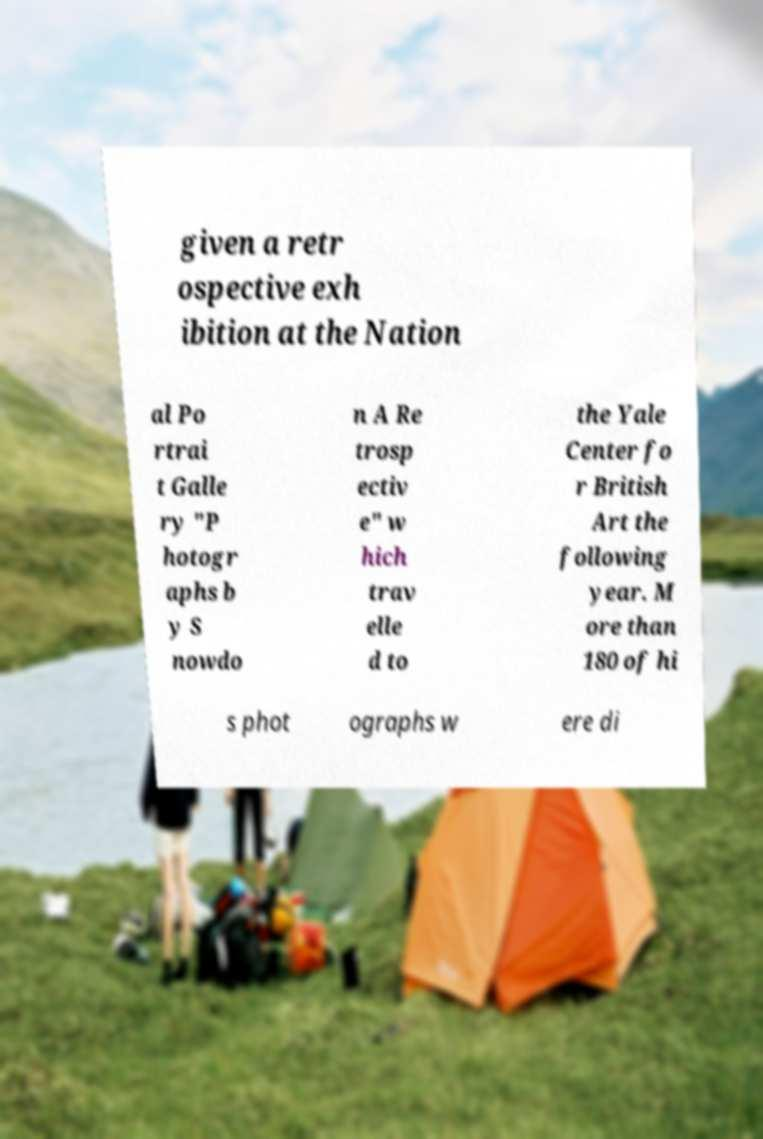Could you extract and type out the text from this image? given a retr ospective exh ibition at the Nation al Po rtrai t Galle ry "P hotogr aphs b y S nowdo n A Re trosp ectiv e" w hich trav elle d to the Yale Center fo r British Art the following year. M ore than 180 of hi s phot ographs w ere di 